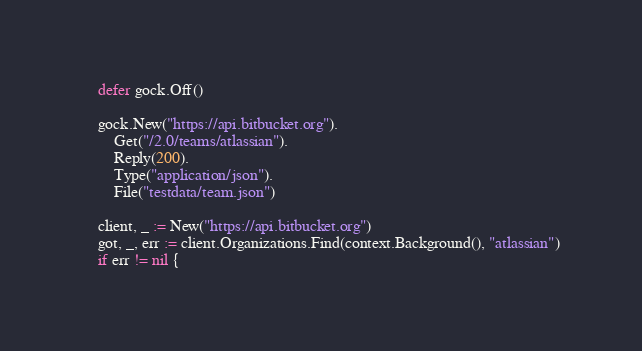<code> <loc_0><loc_0><loc_500><loc_500><_Go_>	defer gock.Off()

	gock.New("https://api.bitbucket.org").
		Get("/2.0/teams/atlassian").
		Reply(200).
		Type("application/json").
		File("testdata/team.json")

	client, _ := New("https://api.bitbucket.org")
	got, _, err := client.Organizations.Find(context.Background(), "atlassian")
	if err != nil {</code> 